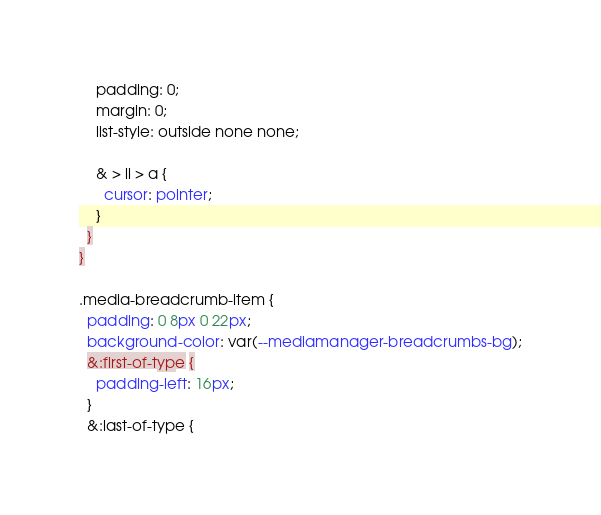<code> <loc_0><loc_0><loc_500><loc_500><_CSS_>    padding: 0;
    margin: 0;
    list-style: outside none none;

    & > li > a {
      cursor: pointer;
    }
  }
}

.media-breadcrumb-item {
  padding: 0 8px 0 22px;
  background-color: var(--mediamanager-breadcrumbs-bg);
  &:first-of-type {
    padding-left: 16px;
  }
  &:last-of-type {</code> 